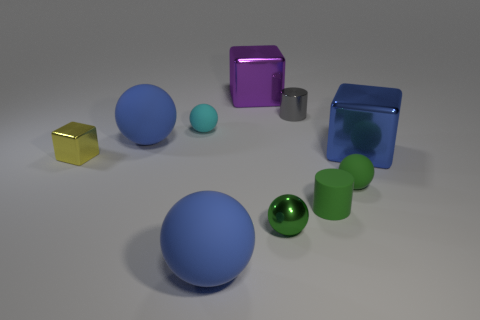There is a block that is both behind the yellow thing and in front of the purple cube; what is it made of?
Give a very brief answer. Metal. What is the shape of the large rubber thing right of the large ball behind the tiny yellow block?
Offer a very short reply. Sphere. Is the tiny cube the same color as the rubber cylinder?
Provide a succinct answer. No. What number of blue objects are big blocks or big matte objects?
Keep it short and to the point. 3. There is a purple metallic block; are there any small blocks in front of it?
Give a very brief answer. Yes. How big is the green metallic ball?
Your answer should be compact. Small. What size is the yellow thing that is the same shape as the large blue metallic thing?
Give a very brief answer. Small. There is a blue thing to the right of the gray shiny object; what number of tiny yellow metal blocks are to the left of it?
Make the answer very short. 1. Are the green thing that is in front of the matte cylinder and the big object behind the tiny gray shiny thing made of the same material?
Keep it short and to the point. Yes. How many other objects have the same shape as the tiny gray object?
Offer a very short reply. 1. 